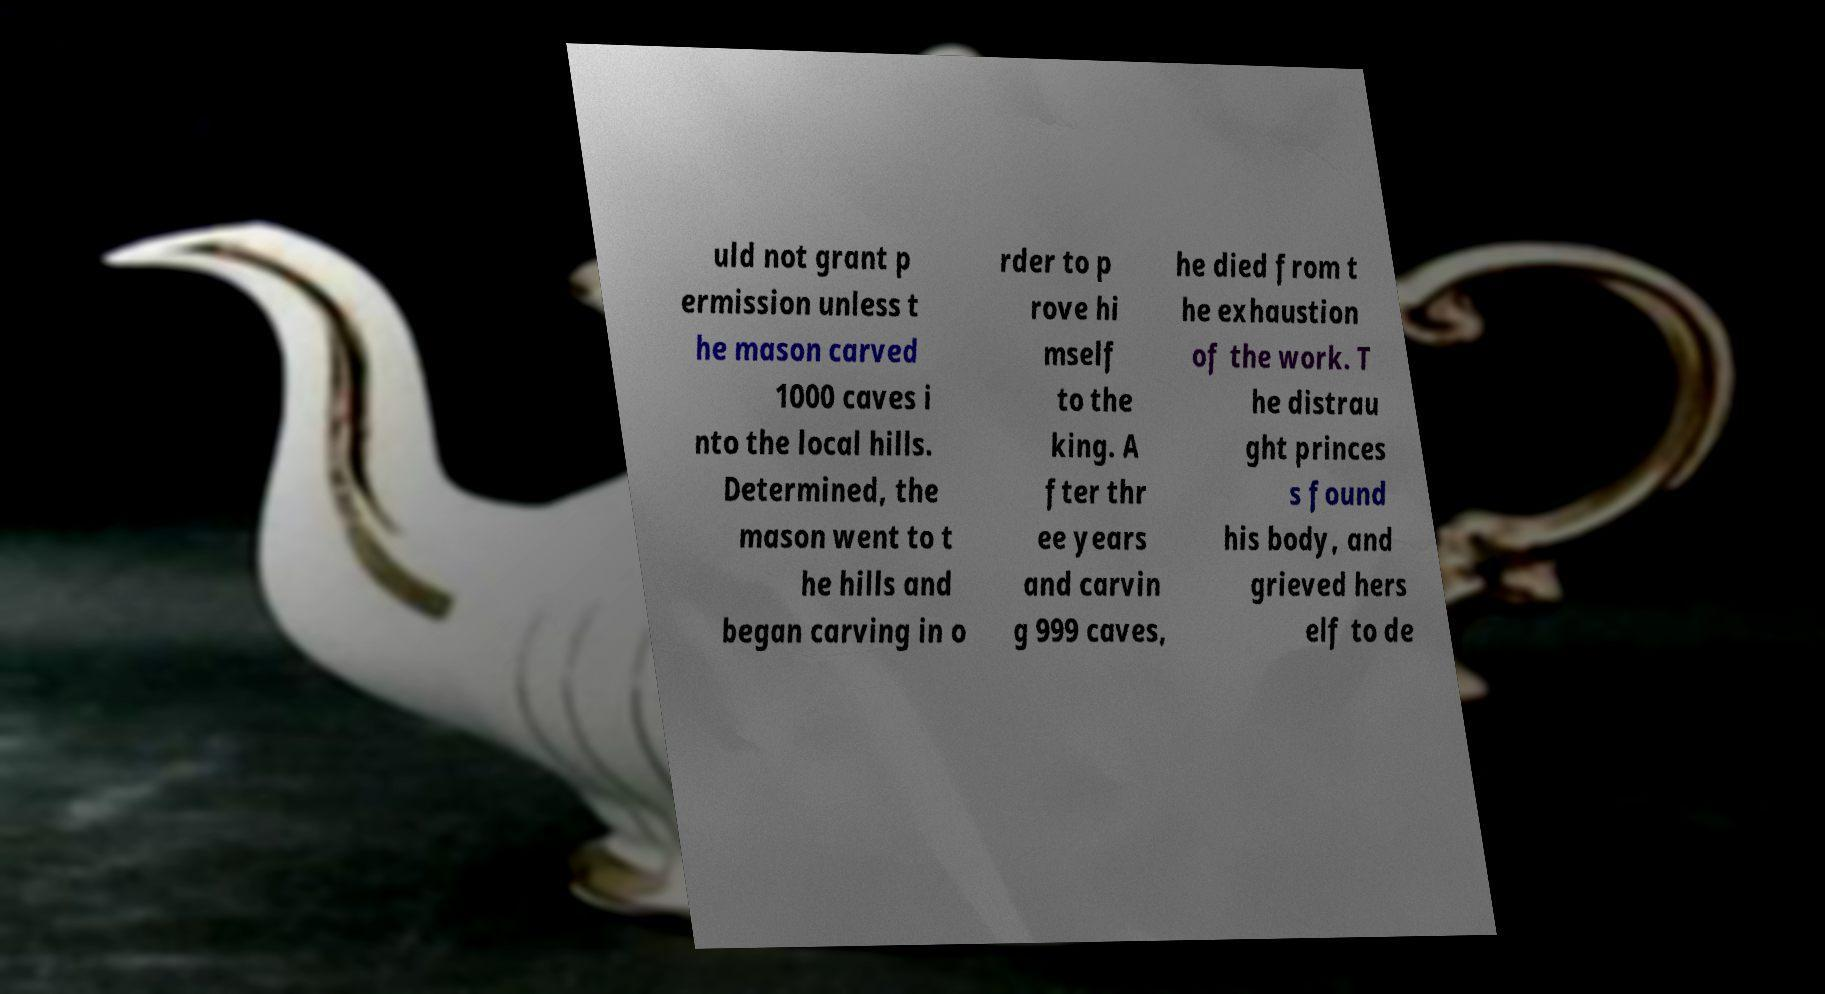Please read and relay the text visible in this image. What does it say? uld not grant p ermission unless t he mason carved 1000 caves i nto the local hills. Determined, the mason went to t he hills and began carving in o rder to p rove hi mself to the king. A fter thr ee years and carvin g 999 caves, he died from t he exhaustion of the work. T he distrau ght princes s found his body, and grieved hers elf to de 